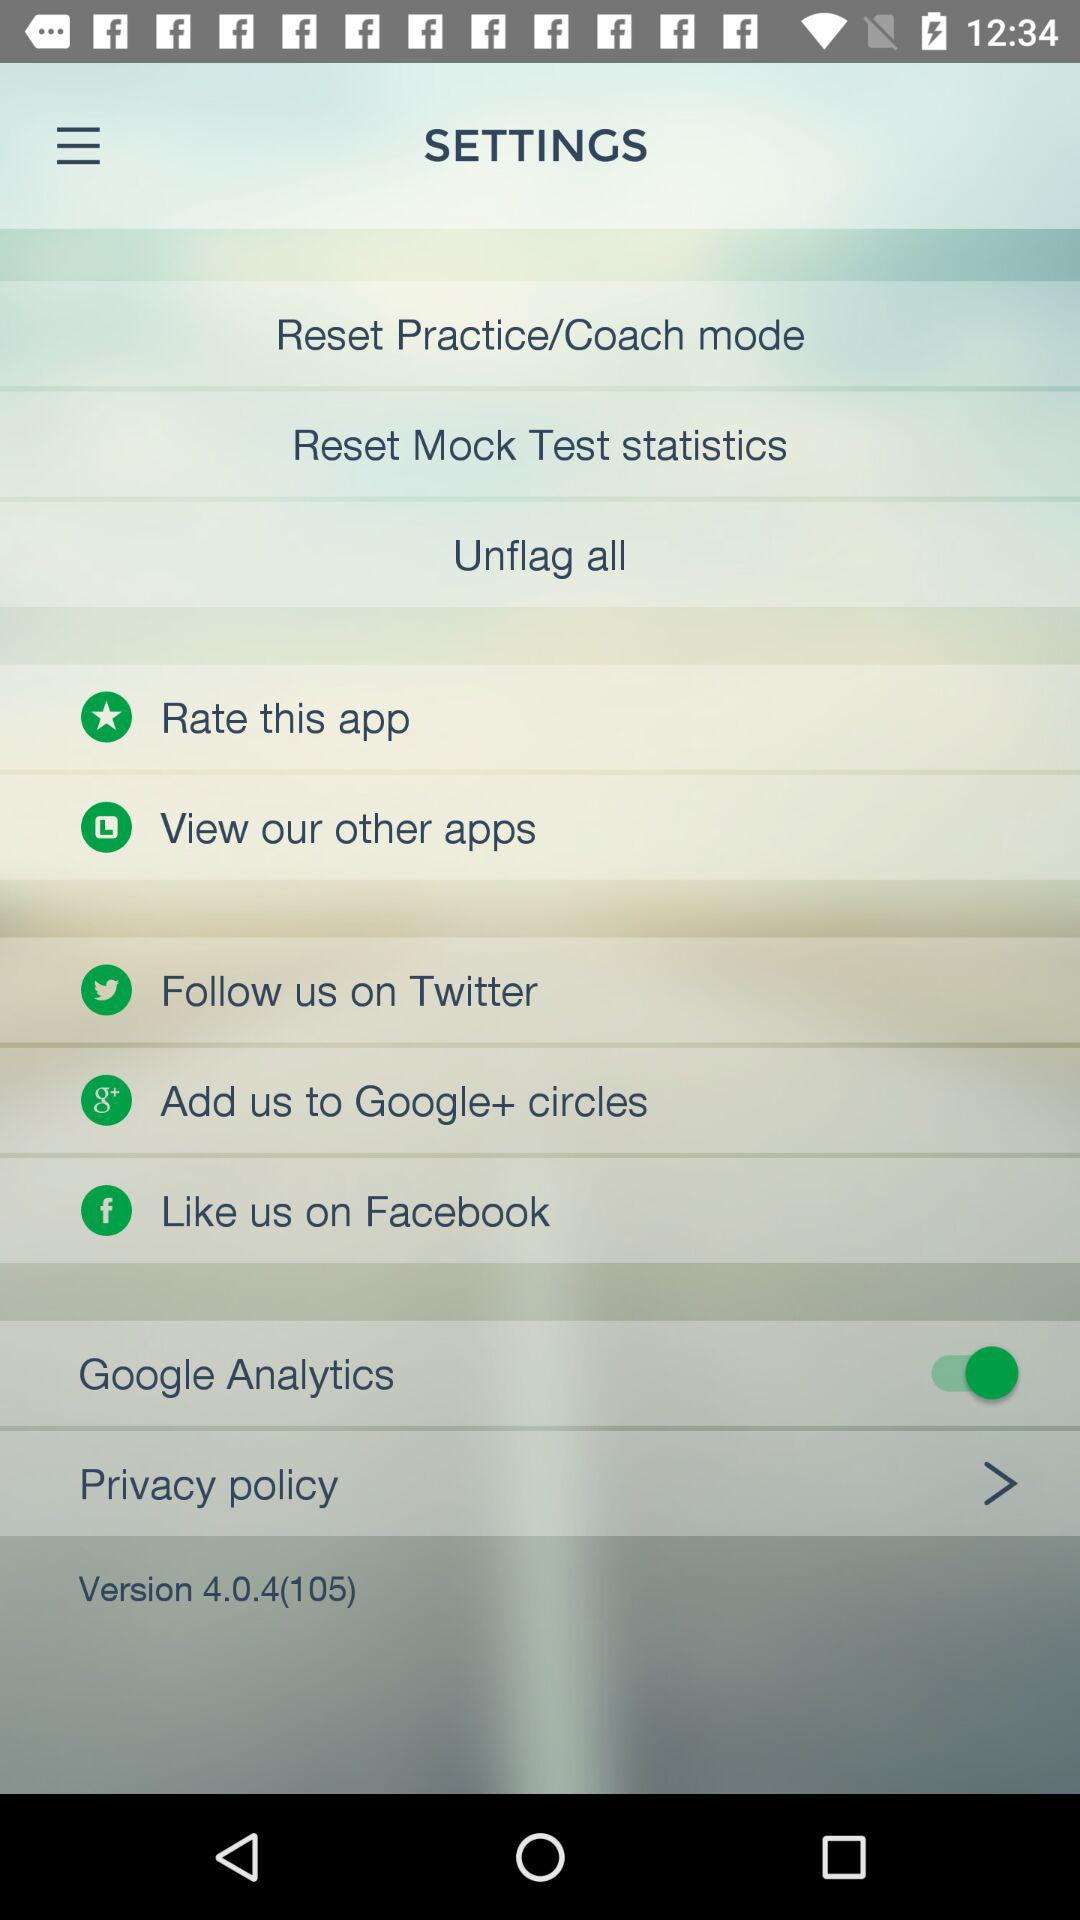What version is there? The version is 4.04(105). 